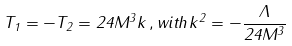<formula> <loc_0><loc_0><loc_500><loc_500>T _ { 1 } = - T _ { 2 } = 2 4 M ^ { 3 } k \, , w i t h \, k ^ { 2 } = - \frac { \Lambda } { 2 4 M ^ { 3 } }</formula> 